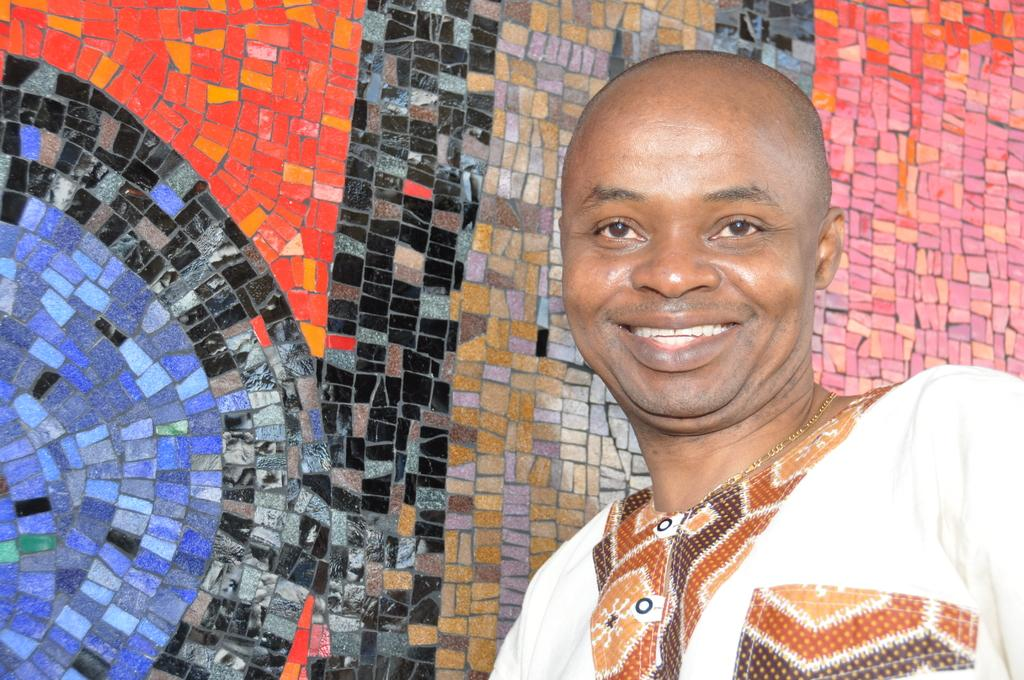What is the person in the image wearing? The person is wearing a white color dress. What expression does the person have? The person is smiling. What can be seen in the background of the image? There is a wall in the background of the image. What colors are present on the wall? Different colors are present on the wall. What channel is the person watching on the wall in the image? There is no television or channel present in the image; it only features a person wearing a white dress and a wall with different colors. What type of jar is visible on the wall in the image? There is no jar present on the wall in the image. 